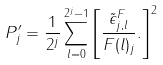<formula> <loc_0><loc_0><loc_500><loc_500>P ^ { \prime } _ { j } = \frac { 1 } { 2 ^ { j } } \sum _ { l = 0 } ^ { 2 ^ { j } - 1 } \left [ \frac { \tilde { \epsilon } ^ { F } _ { j , l } } { F ( l ) _ { j } } . \right ] ^ { 2 }</formula> 